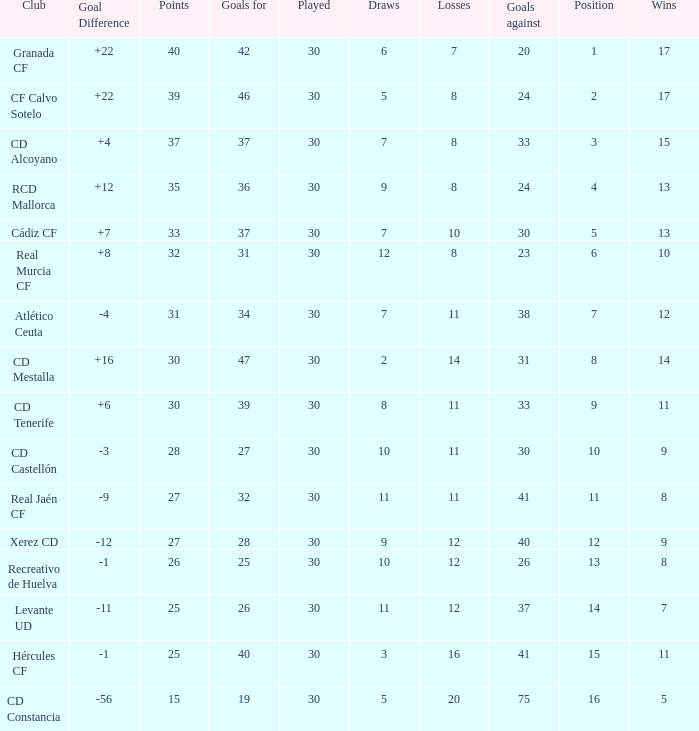Parse the full table. {'header': ['Club', 'Goal Difference', 'Points', 'Goals for', 'Played', 'Draws', 'Losses', 'Goals against', 'Position', 'Wins'], 'rows': [['Granada CF', '+22', '40', '42', '30', '6', '7', '20', '1', '17'], ['CF Calvo Sotelo', '+22', '39', '46', '30', '5', '8', '24', '2', '17'], ['CD Alcoyano', '+4', '37', '37', '30', '7', '8', '33', '3', '15'], ['RCD Mallorca', '+12', '35', '36', '30', '9', '8', '24', '4', '13'], ['Cádiz CF', '+7', '33', '37', '30', '7', '10', '30', '5', '13'], ['Real Murcia CF', '+8', '32', '31', '30', '12', '8', '23', '6', '10'], ['Atlético Ceuta', '-4', '31', '34', '30', '7', '11', '38', '7', '12'], ['CD Mestalla', '+16', '30', '47', '30', '2', '14', '31', '8', '14'], ['CD Tenerife', '+6', '30', '39', '30', '8', '11', '33', '9', '11'], ['CD Castellón', '-3', '28', '27', '30', '10', '11', '30', '10', '9'], ['Real Jaén CF', '-9', '27', '32', '30', '11', '11', '41', '11', '8'], ['Xerez CD', '-12', '27', '28', '30', '9', '12', '40', '12', '9'], ['Recreativo de Huelva', '-1', '26', '25', '30', '10', '12', '26', '13', '8'], ['Levante UD', '-11', '25', '26', '30', '11', '12', '37', '14', '7'], ['Hércules CF', '-1', '25', '40', '30', '3', '16', '41', '15', '11'], ['CD Constancia', '-56', '15', '19', '30', '5', '20', '75', '16', '5']]} How many Draws have 30 Points, and less than 33 Goals against? 1.0. 